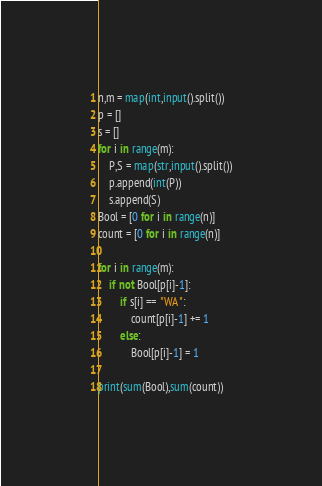<code> <loc_0><loc_0><loc_500><loc_500><_Python_>n,m = map(int,input().split())
p = []
s = []
for i in range(m):
    P,S = map(str,input().split())
    p.append(int(P))
    s.append(S)
Bool = [0 for i in range(n)]
count = [0 for i in range(n)]

for i in range(m):
    if not Bool[p[i]-1]:
        if s[i] == "WA":
            count[p[i]-1] += 1
        else:
            Bool[p[i]-1] = 1

print(sum(Bool),sum(count))</code> 